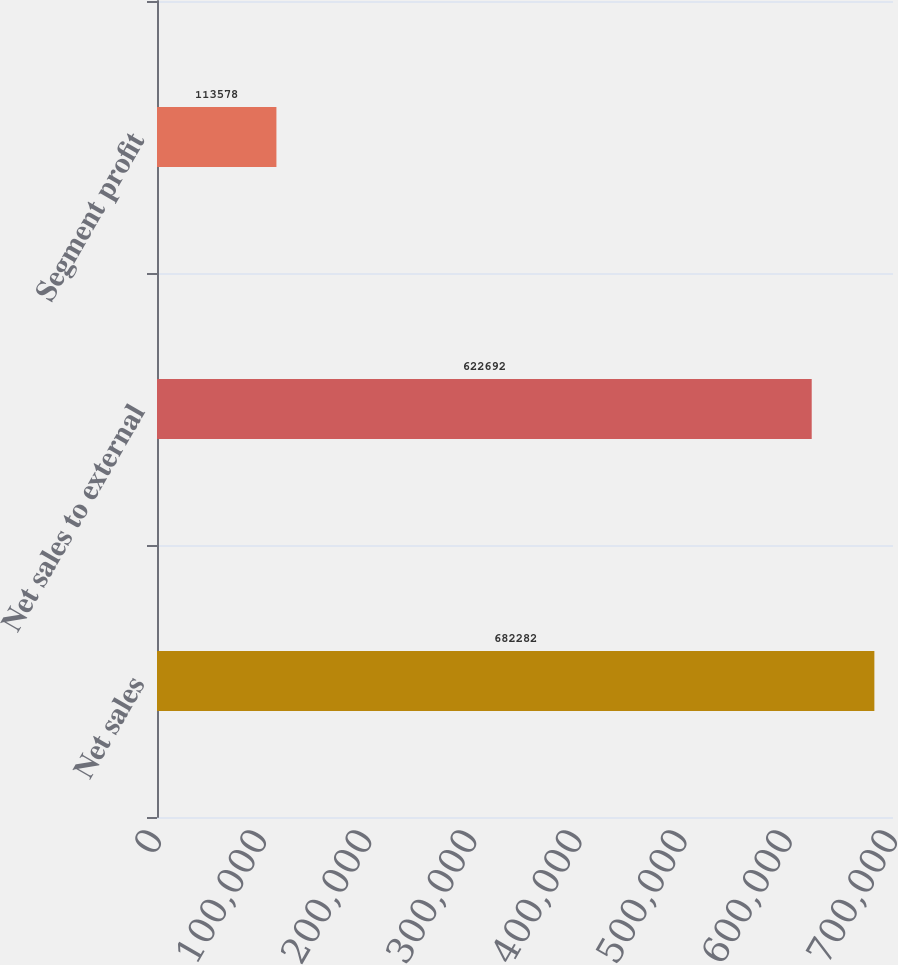Convert chart. <chart><loc_0><loc_0><loc_500><loc_500><bar_chart><fcel>Net sales<fcel>Net sales to external<fcel>Segment profit<nl><fcel>682282<fcel>622692<fcel>113578<nl></chart> 